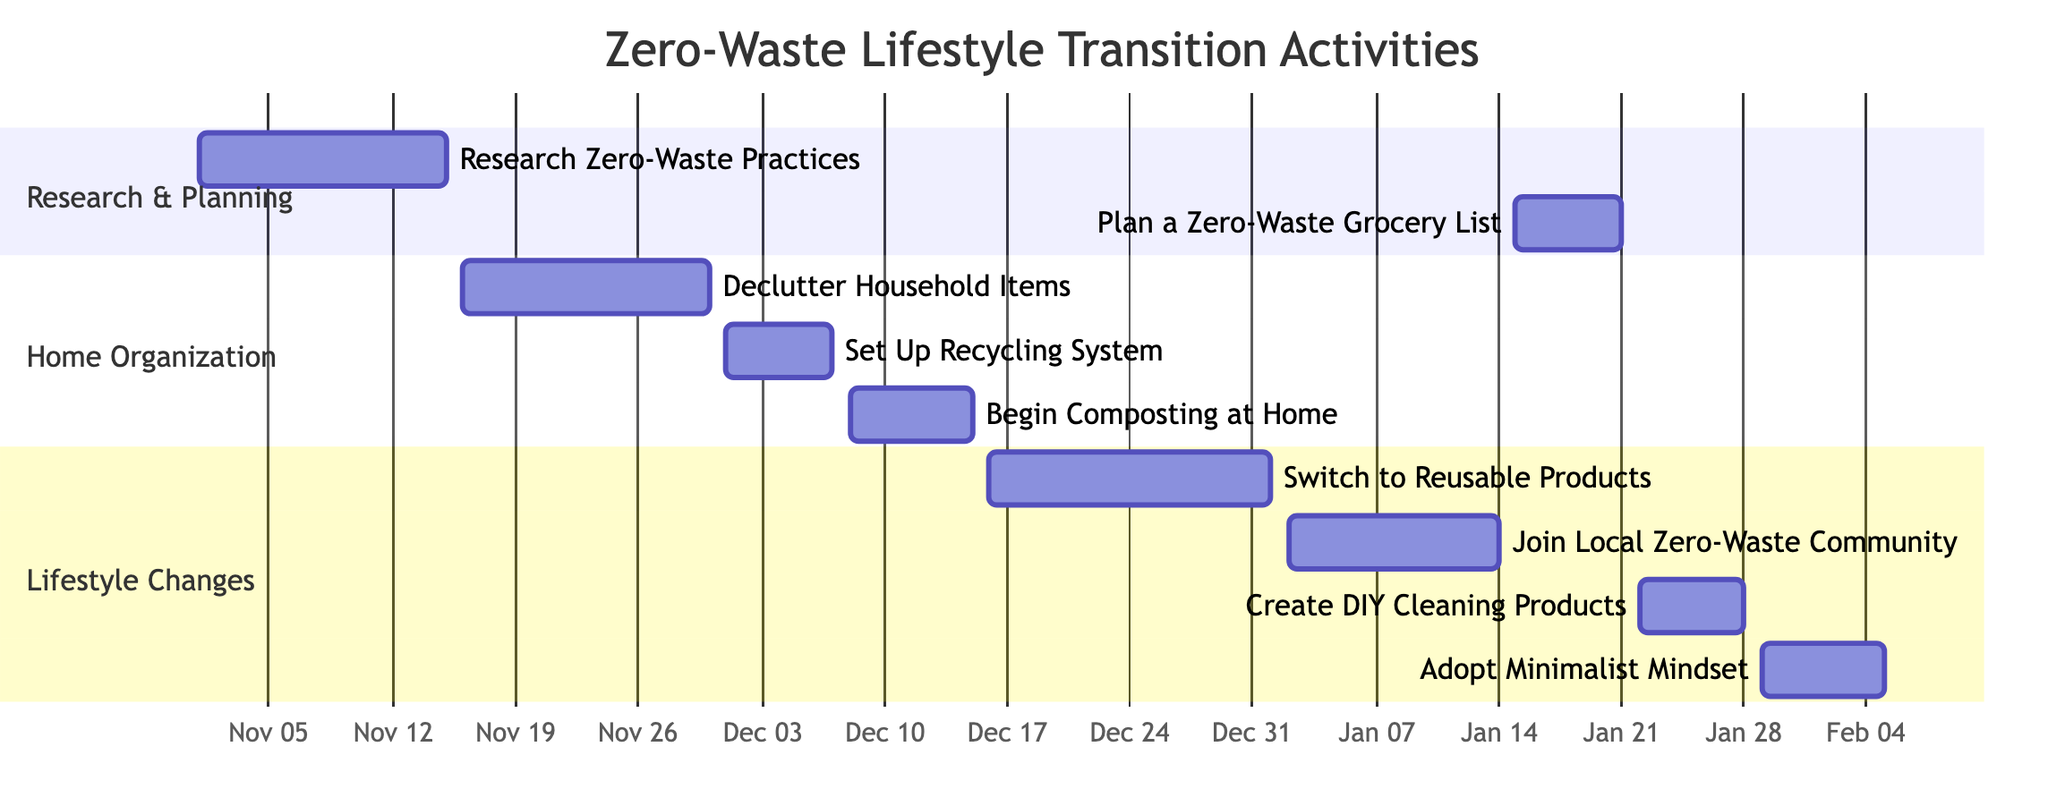What is the duration of the "Set Up Recycling System" activity? The "Set Up Recycling System" activity starts on December 1, 2023, and ends on December 7, 2023. To find the duration, count the days between those two dates, which is 7 days.
Answer: 7 days What is the first activity in the "Home Organization" section? The "Home Organization" section features three activities. The first one, listed in chronological order, is "Declutter Household Items," which starts on November 16, 2023.
Answer: Declutter Household Items How many activities are scheduled between November 16 and December 15, 2023? Within the specified date range, there are three activities: "Declutter Household Items" (November 16-30), "Set Up Recycling System" (December 1-7), and "Begin Composting at Home" (December 8-15). By adding them up, we find there are a total of three activities.
Answer: 3 What activity follows "Join Local Zero-Waste Community"? "Join Local Zero-Waste Community" ends on January 14, 2024. The next activity in chronological order is "Create DIY Cleaning Products," which starts on January 22, 2024.
Answer: Create DIY Cleaning Products Which activity intersects with both "Switch to Reusable Products" and "Begin Composting at Home"? The "Switch to Reusable Products" activity runs from December 16, 2023, to January 1, 2024, while "Begin Composting at Home" runs from December 8 to December 15, 2023. There is no overlap between these two. Thus, there is no activity that intersects.
Answer: None What is the last activity in the Gantt chart? To determine the last activity, I will check the end dates of all activities. The last activity is "Adopt Minimalist Mindset," which has an end date of February 5, 2024.
Answer: Adopt Minimalist Mindset 